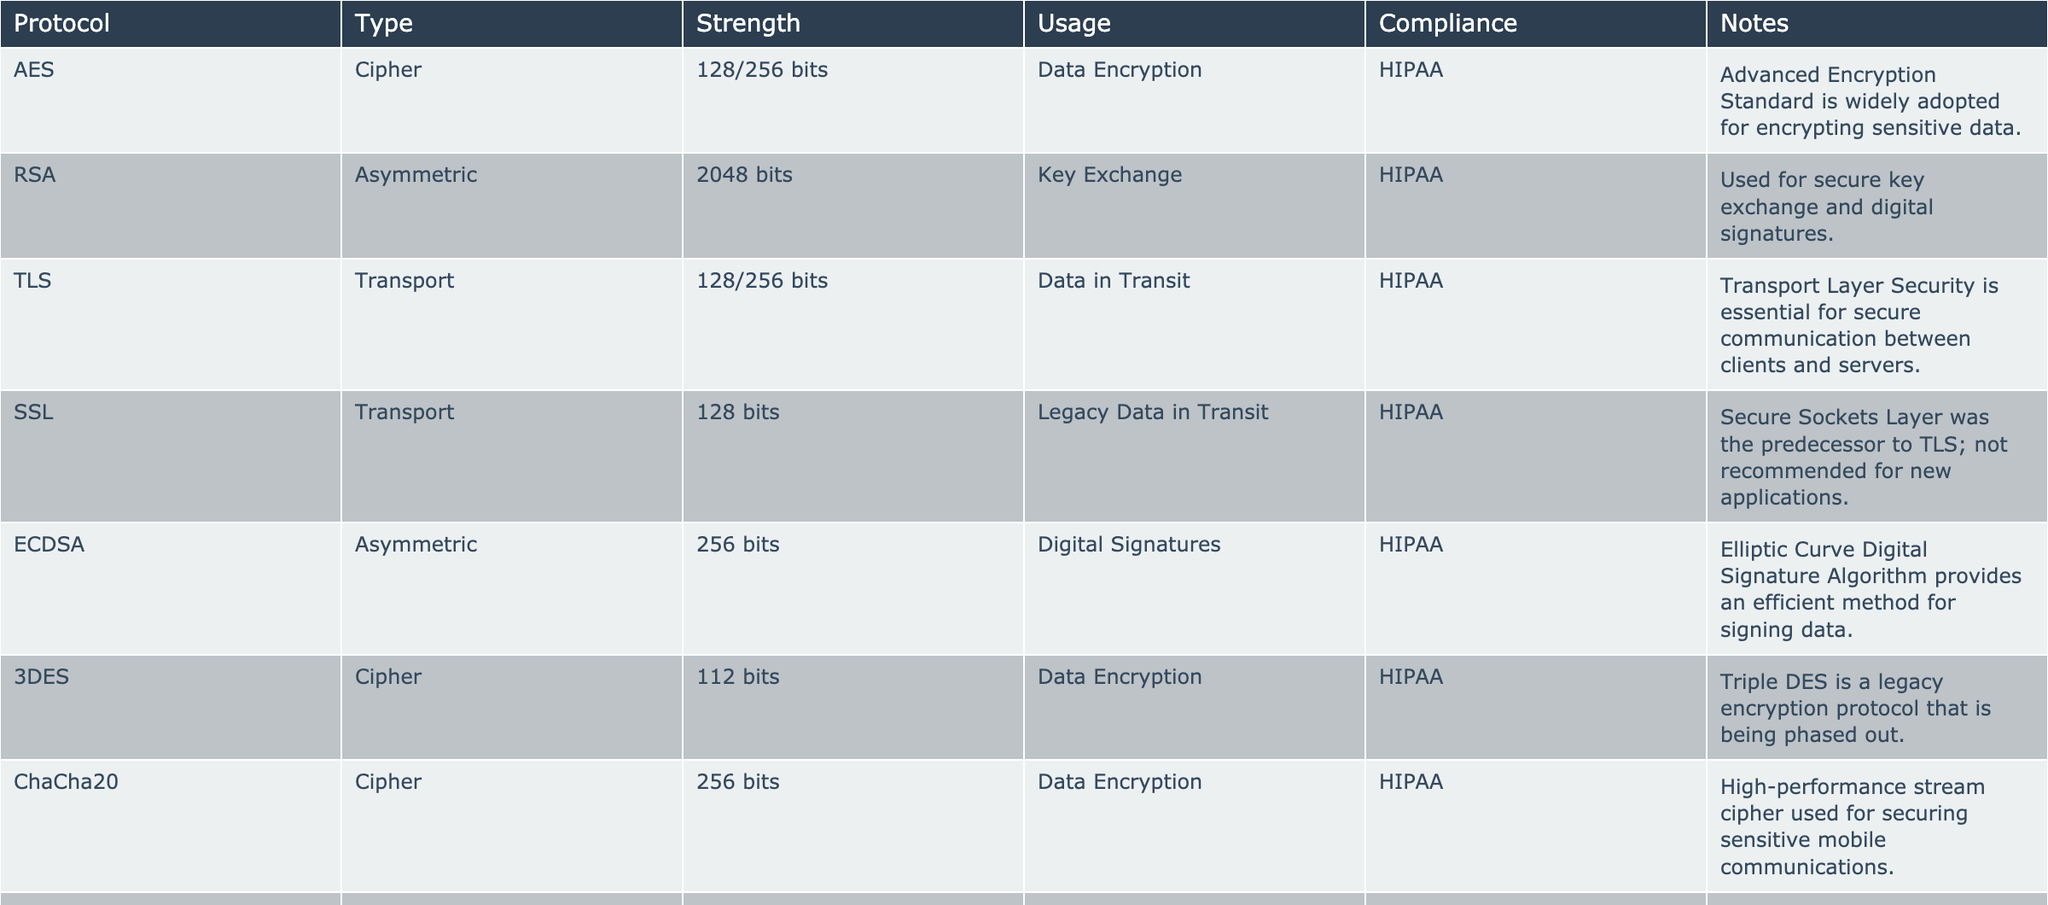What is the most commonly used encryption protocol for data encryption? The table lists several encryption protocols, and under the Usage column, AES is marked for Data Encryption. It is also noted that the Advanced Encryption Standard is widely adopted.
Answer: AES Which encryption protocol provides digital signatures? Looking at the Usage column, ECDSA is listed under Digital Signatures. It also specifies that it utilizes 256-bit strength.
Answer: ECDSA What is the strength of the RSA encryption protocol? The table specifies that RSA uses a strength of 2048 bits and is classified as an Asymmetric protocol.
Answer: 2048 bits How many encryption protocols are designated for data in transit? By scanning the table, we find that 3 protocols are identified under the Usage column for Data in Transit: TLS, SSL, and VPN.
Answer: 3 Is SSL still recommended for new applications? The notes for SSL indicate that it is not recommended for new applications, which implies a negative response to this question.
Answer: No Which encryption protocol uses the highest available strength from the table? Among the available options, RSA at 2048 bits and ECDSA at 256 bits are the highest listed. Since RSA has a higher bit strength, it holds the title.
Answer: RSA What is the purpose of HMAC in mobile app development? HMAC is described as a method for verifying the authenticity and integrity of messages in the table, this identifies its purpose clearly.
Answer: Verify message integrity Can you list all encryption protocols that have been designated as HIPAA compliant? The entire table indicates that all listed protocols are HIPAA compliant, confirming that every one of them adheres to this standard.
Answer: All protocols listed Which encryption protocol is considered legacy and is being phased out? The table indicates that 3DES is categorized as legacy and is mentioned as being phased out.
Answer: 3DES What is the relationship between encryption protocols and HIPAA compliance in this table? Each listed protocol indicates HIPAA compliance, suggesting all these encryption methods are suitable for use in healthcare applications.
Answer: All are HIPAA compliant 